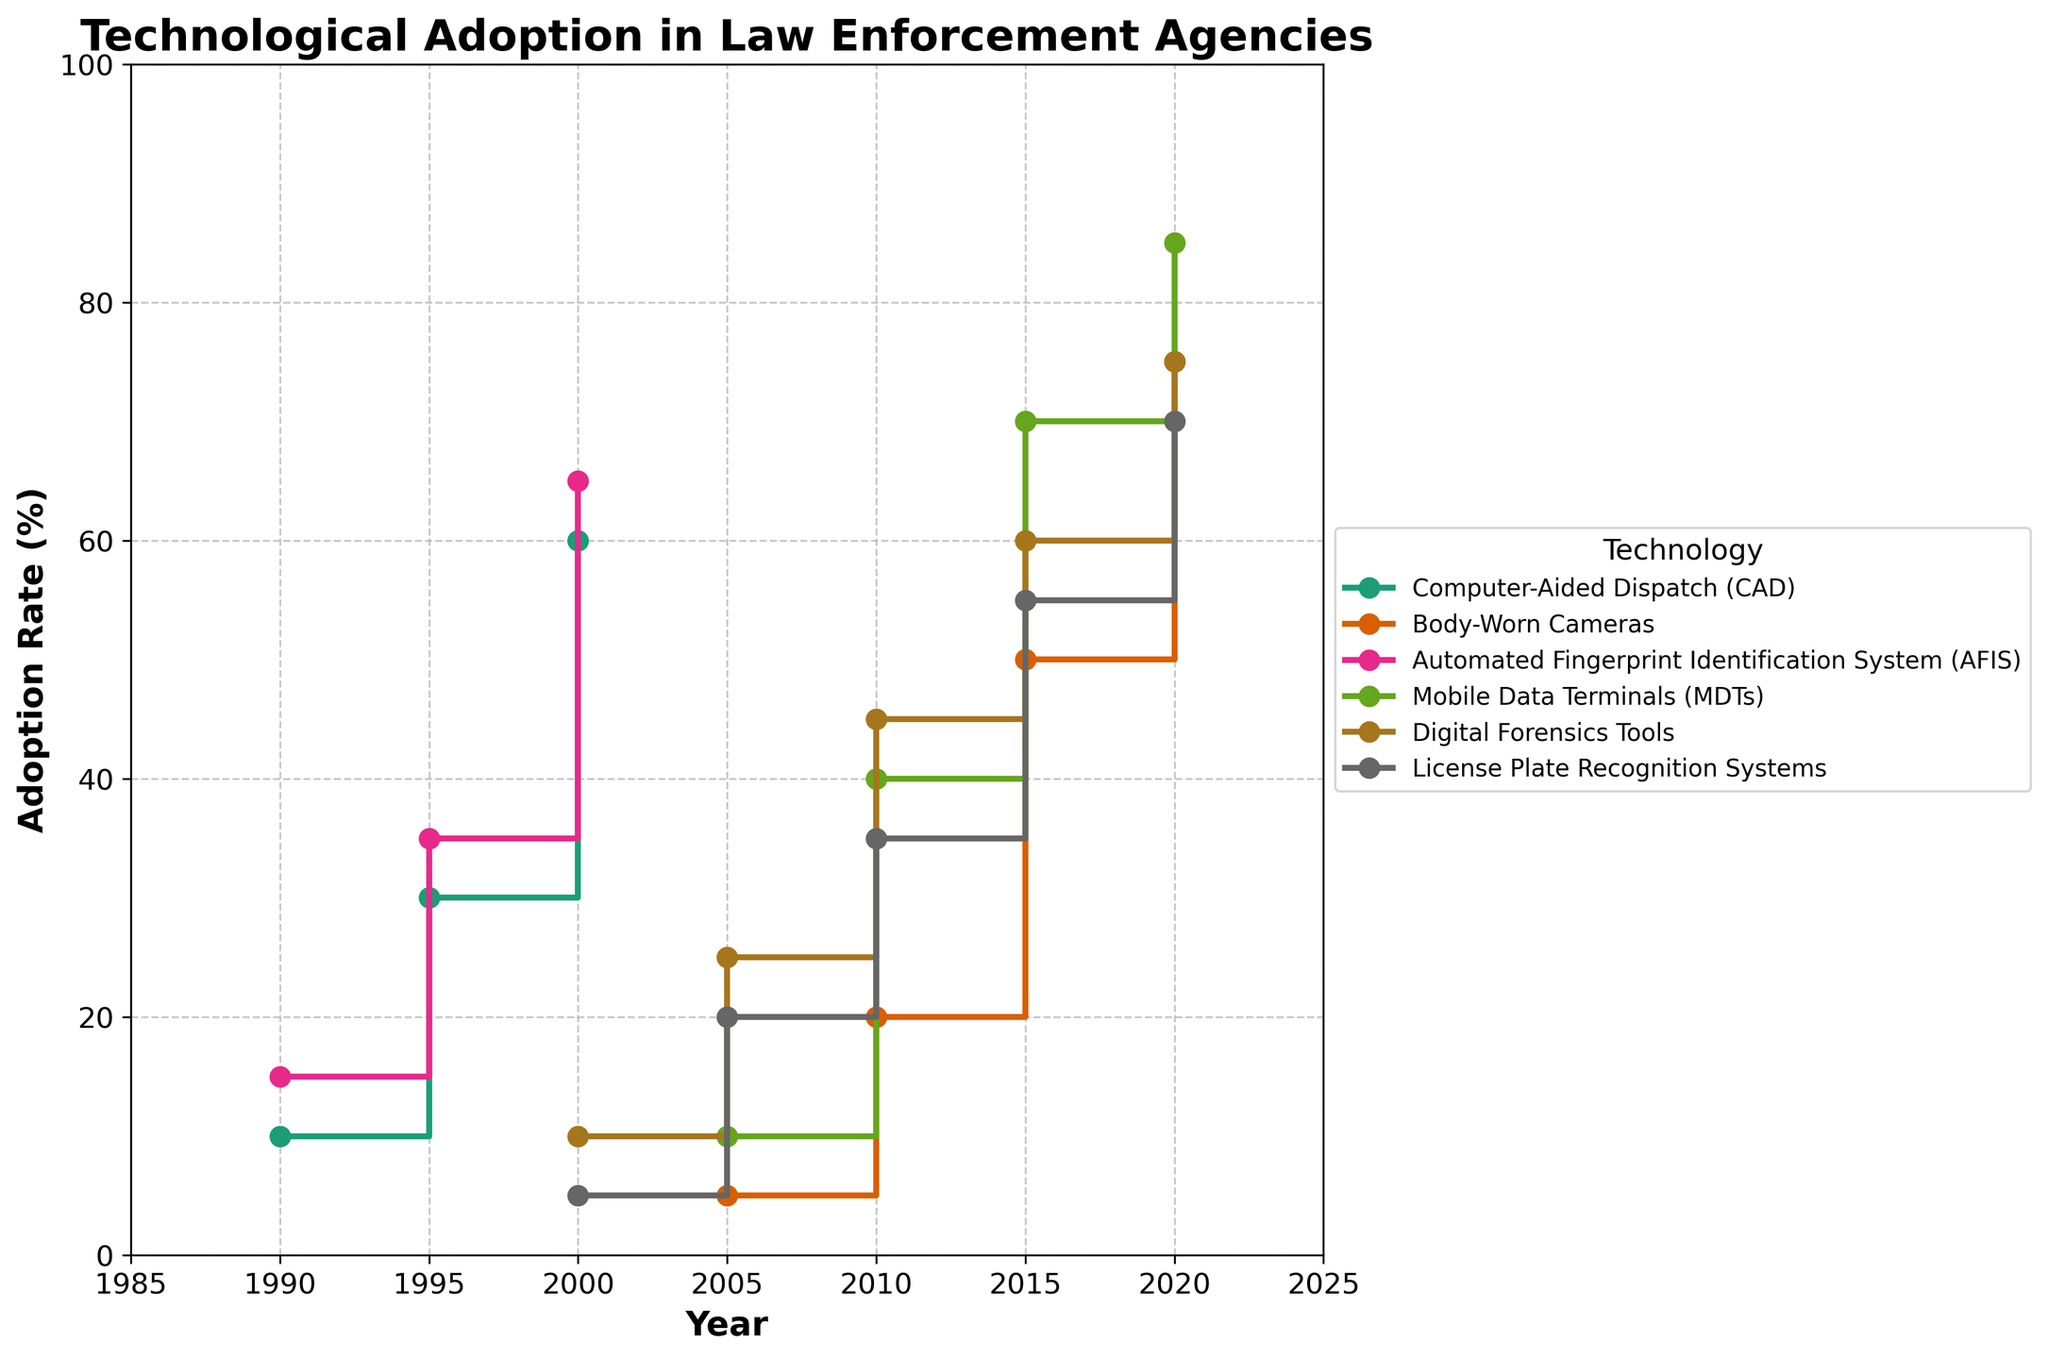What technology had the highest adoption rate in 1990? The adopted rates of the technologies in 1990 are observed: CAD at 10%, Body-Worn Cameras not yet adopted, AFIS at 15%, MDTs not yet adopted, Digital Forensics Tools not yet adopted, and License Plate Recognition Systems not yet adopted. Therefore, AFIS has the highest adoption rate in 1990.
Answer: AFIS What is the adoption rate difference of Computer-Aided Dispatch (CAD) between 1990 and 2000? Refer to the steps for CAD in the figure, noting the adoption rate in 1990 is 10% and in 2000 is 60%. Subtract 10% from 60% to get the difference.
Answer: 50% Which technology had a greater adoption rate in 2015, Body-Worn Cameras or Mobile Data Terminals (MDTs)? Compare the adoption rates in 2015: Body-Worn Cameras are at 50%, and MDTs are at 70%. Since 70% is greater than 50%, MDTs had a greater adoption rate.
Answer: MDTs Between which years did License Plate Recognition Systems see the biggest jump in adoption rate? Examine the steps for License Plate Recognition Systems: 2000 (5%), 2005 (20%), 2010 (35%), 2015 (55%), 2020 (70%). The largest increase occurs between 2000 and 2005, with a difference of 15%.
Answer: 2000-2005 By how much did the adoption rate of Digital Forensics Tools increase from 2005 to 2010? The adoption rates of Digital Forensics Tools are 25% in 2005 and 45% in 2010. Subtract the 2005 rate from the 2010 rate: 45% - 25% = 20%.
Answer: 20% What is the adoption rate of the technology with the lowest adoption rate in 2020? In 2020, the adoption rates across technologies are: CAD at 60%, Body-Worn Cameras at 75%, AFIS at 65%, MDTs at 85%, Digital Forensics Tools at 75%, and License Plate Recognition Systems at 70%. CAD has the lowest adoption rate.
Answer: 60% Which technology saw the earliest recorded adoption, and what was the rate? Identify the earliest year for each technology: CAD in 1990 at 10%, Body-Worn Cameras in 2005 at 5%, AFIS in 1990 at 15%, MDTs in 2005 at 10%, Digital Forensics Tools in 2000 at 10%, and License Plate Recognition Systems in 2000 at 5%. AFIS and CAD both started in 1990, but AFIS has a higher initial rate.
Answer: AFIS, 15% How many technologies reached an adoption rate of at least 70% by 2020? Look at the 2020 data points: CAD at 60%, Body-Worn Cameras at 75%, AFIS at 65%, MDTs at 85%, Digital Forensics Tools at 75%, and License Plate Recognition Systems at 70%. Body-Worn Cameras, MDTs, Digital Forensics Tools, and License Plate Recognition Systems reached or exceeded 70%.
Answer: 4 Was the adoption of any technology stagnant over a period? Check each technological adoption step for consistency over subsequent years. All technologies show increases in adoption rates, none of them remain stagnant over the given periods.
Answer: No 